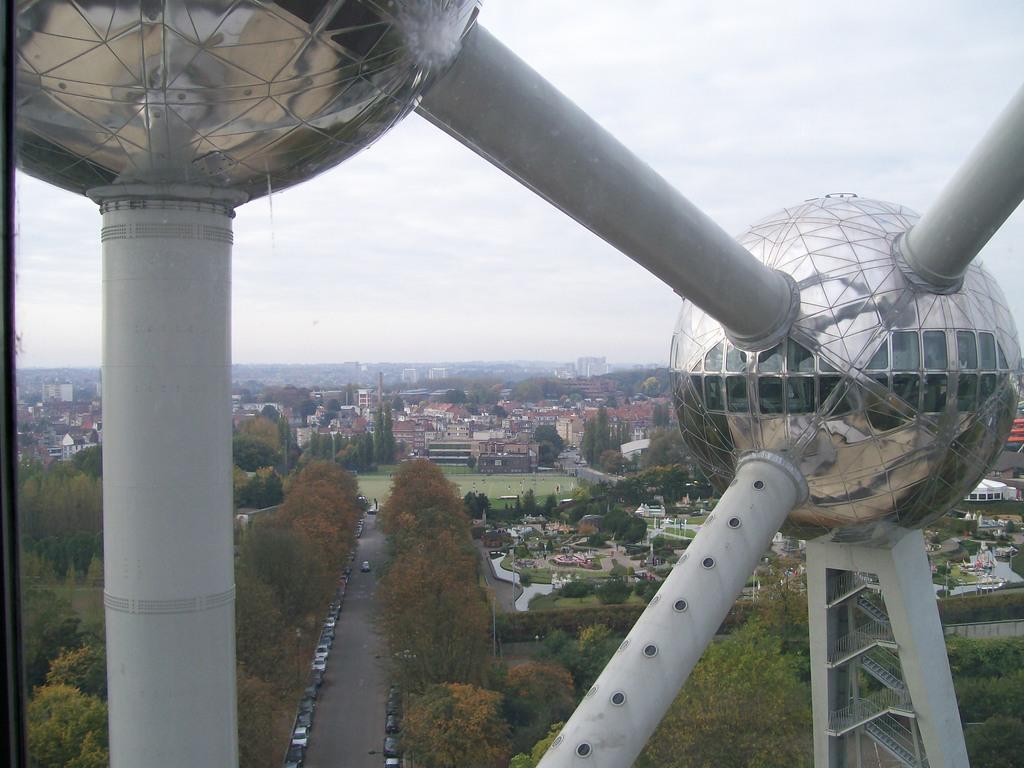Describe this image in one or two sentences. In the picture we can see a construction of balls and poles to it jointing and from it we can see an Ariel view of the road and some vehicles are parked near it and trees and behind it, we can see grass surface and houses, buildings and in the background we can see a hill and sky. 